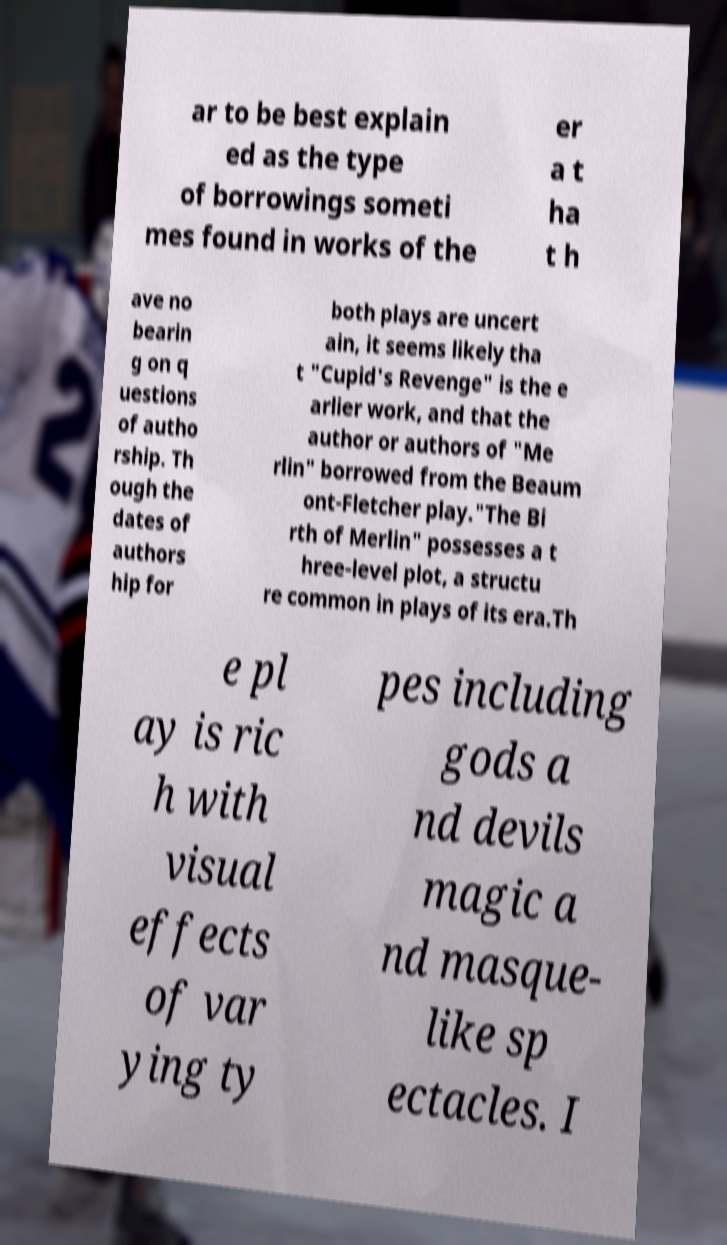What messages or text are displayed in this image? I need them in a readable, typed format. ar to be best explain ed as the type of borrowings someti mes found in works of the er a t ha t h ave no bearin g on q uestions of autho rship. Th ough the dates of authors hip for both plays are uncert ain, it seems likely tha t "Cupid's Revenge" is the e arlier work, and that the author or authors of "Me rlin" borrowed from the Beaum ont-Fletcher play."The Bi rth of Merlin" possesses a t hree-level plot, a structu re common in plays of its era.Th e pl ay is ric h with visual effects of var ying ty pes including gods a nd devils magic a nd masque- like sp ectacles. I 